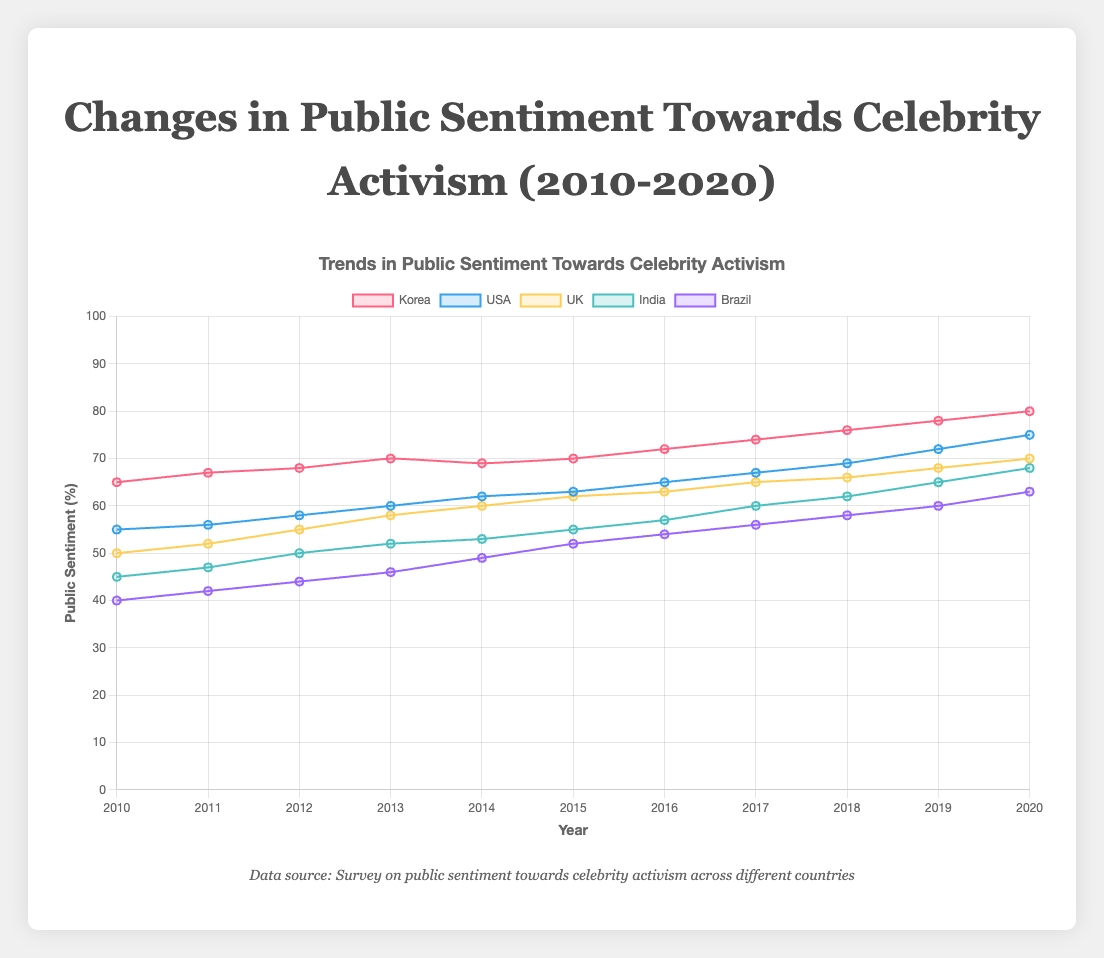What's the average public sentiment towards celebrity activism in Korea from 2010 to 2020? To find the average sentiment in Korea, sum up all the sentiment values from 2010 to 2020 and divide by the number of years. The values are 65, 67, 68, 70, 69, 70, 72, 74, 76, 78, and 80. Sum = 65 + 67 + 68 + 70 + 69 + 70 + 72 + 74 + 76 + 78 + 80 = 789. Divide by 11 (the number of years) to get the average: 789 / 11 ≈ 71.73
Answer: 71.73 Between the USA and UK, which country shows a higher growth in public sentiment from 2010 to 2020? Calculate the difference in public sentiment from 2010 to 2020 for both the USA and the UK. For the USA, the difference is 75 (2020) - 55 (2010) = 20. For the UK, the difference is 70 (2020) - 50 (2010) = 20. Since both countries show the same growth, the answer is neither; both had the same increase.
Answer: Both In 2014, which country had the lowest public sentiment towards celebrity activism? By looking at the data for 2014, the public sentiment values are: Korea (69), USA (62), UK (60), India (53), Brazil (49). The lowest value is for Brazil.
Answer: Brazil Which country's public sentiment towards celebrity activism increased the most from 2013 to 2014? Calculate the difference in public sentiment from 2013 to 2014 for each country. Korea: 69 (2014) - 70 (2013) = -1; USA: 62 (2014) - 60 (2013) = 2; UK: 60 (2014) - 58 (2013) = 2; India: 53 (2014) - 52 (2013) = 1; Brazil: 49 (2014) - 46 (2013) = 3. Brazil has the highest increase at 3.
Answer: Brazil What is the total public sentiment score across all surveyed countries in 2020? Add the sentiment values of all countries for the year 2020: Korea (80), USA (75), UK (70), India (68), Brazil (63). Total = 80 + 75 + 70 + 68 + 63 = 356.
Answer: 356 During which year did India's public sentiment towards celebrity activism surpass that of Brazil for the first time? By comparing year-wise data, we see that Brazil (46) was more than India (45) in 2010, Brazil (49) was more than India (47) in 2011, in 2012, Brazil (44) was less than India (50). So, the year is 2012.
Answer: 2012 Which year shows the highest increase in public sentiment in the USA? To find the highest year-on-year increase, calculate the differences: 2011-2010 (1), 2012-2011 (2), 2013-2012 (2), 2014-2013 (2), 2015-2014 (1), 2016-2015 (2), 2017-2016 (2), 2018-2017 (2), 2019-2018 (3), 2020-2019 (3). The highest increases occurred in 2019-2020 and 2018-2019, both with an increase of 3.
Answer: 2019 and 2020 How does the change in public sentiment from 2010 to 2020 in India compare to that in Brazil? Calculate the differences for both countries from 2010 to 2020. India: 68 (2020) - 45 (2010) = 23. Brazil: 63 (2020) - 40 (2010) = 23. Both countries have an equal change of 23.
Answer: Equal 